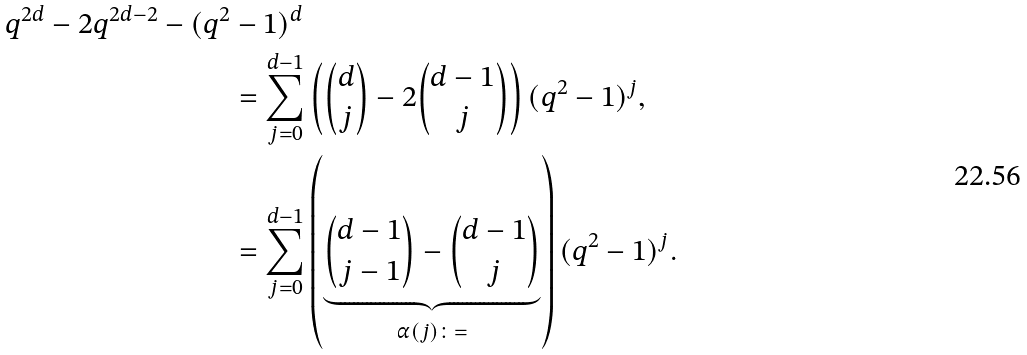Convert formula to latex. <formula><loc_0><loc_0><loc_500><loc_500>q ^ { 2 d } - 2 q ^ { 2 d - 2 } - ( q ^ { 2 } & - 1 ) ^ { d } \\ & = \sum _ { j = 0 } ^ { d - 1 } \left ( \binom { d } { j } - 2 \binom { d - 1 } { j } \right ) ( q ^ { 2 } - 1 ) ^ { j } , \\ & = \sum _ { j = 0 } ^ { d - 1 } \left ( \underbrace { \binom { d - 1 } { j - 1 } - \binom { d - 1 } { j } } _ { \alpha ( j ) \colon = } \right ) ( q ^ { 2 } - 1 ) ^ { j } .</formula> 